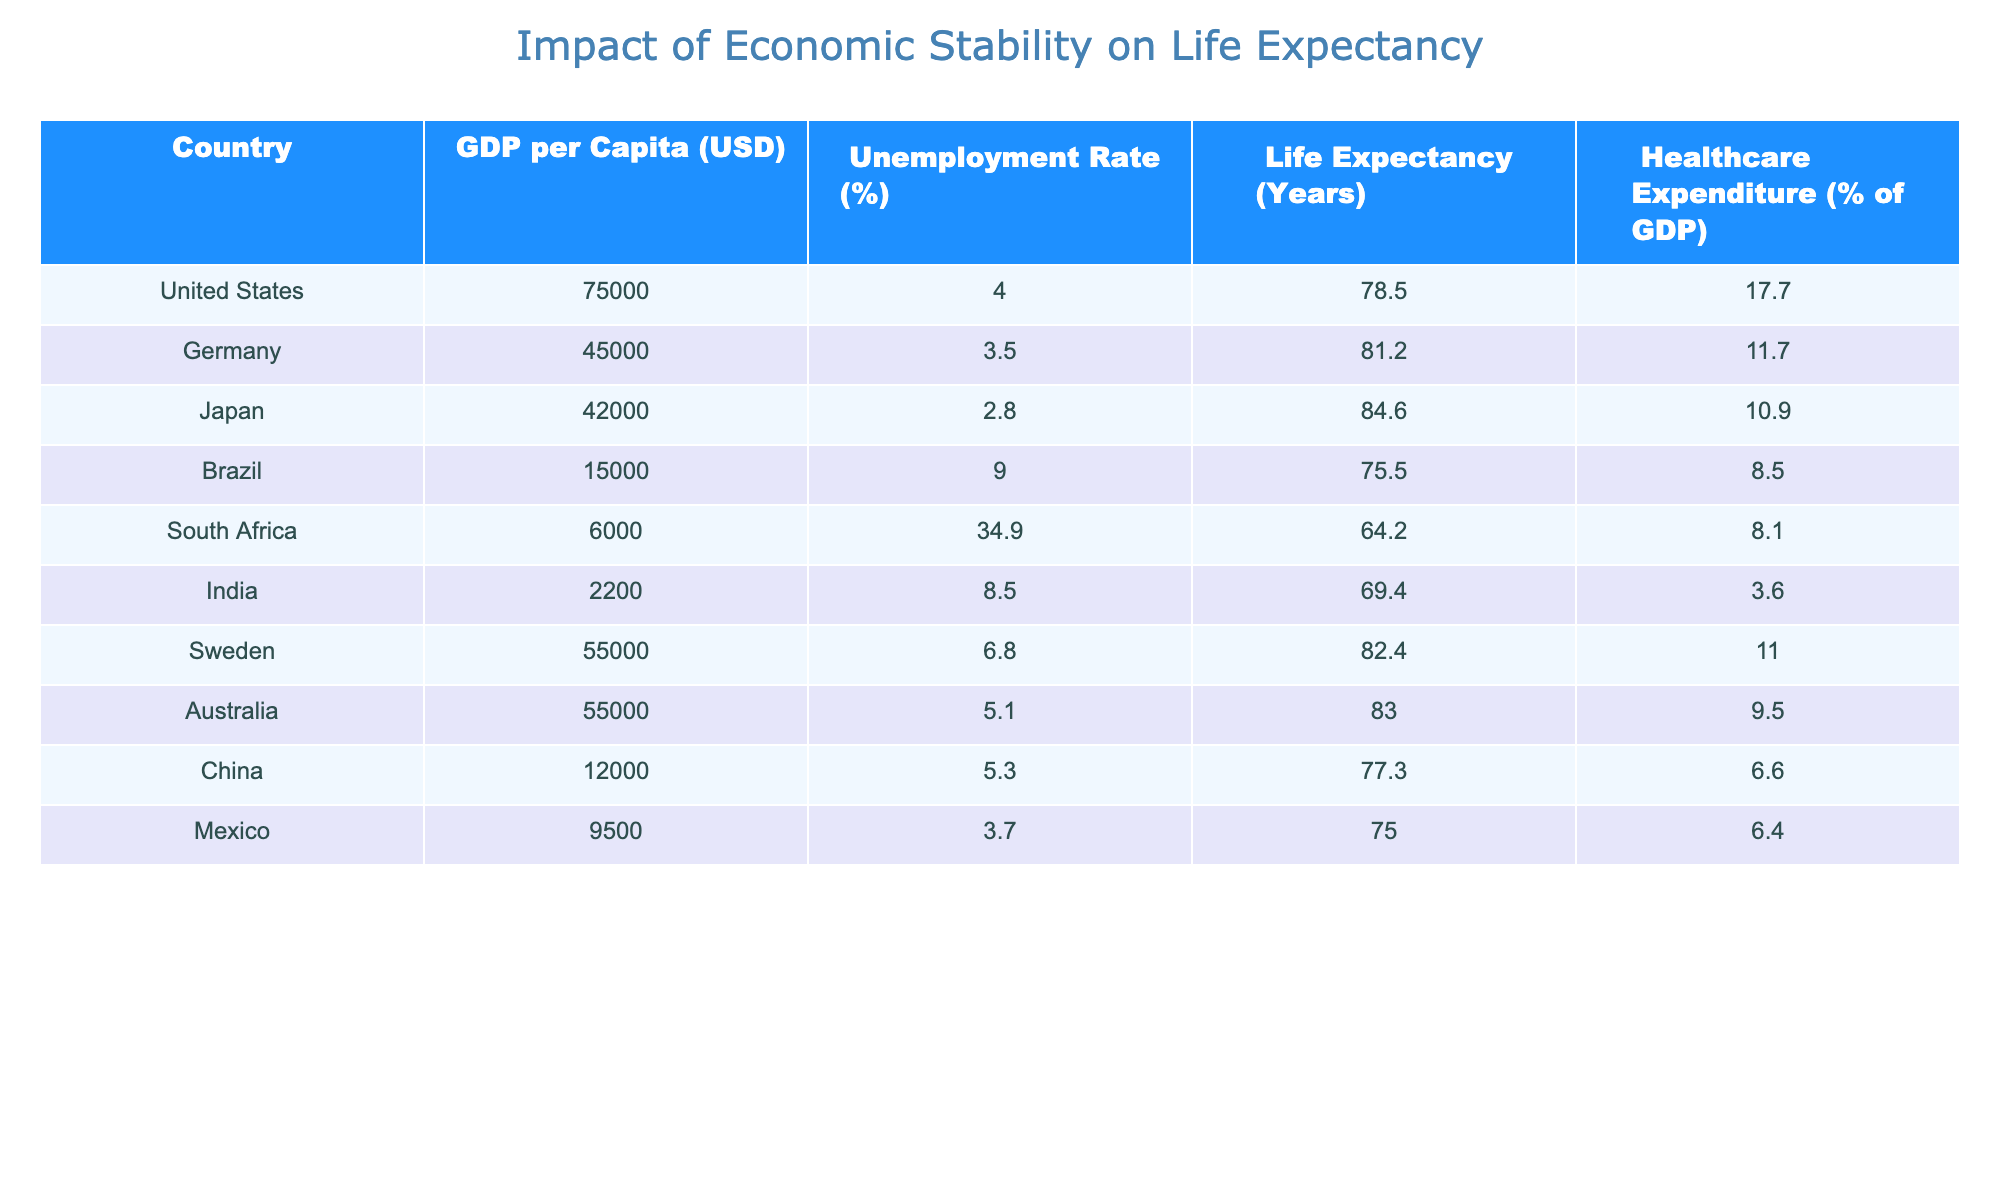What is the life expectancy in Japan? The life expectancy for Japan is listed directly in the table. Looking at the "Life Expectancy (Years)" column for Japan provides the value.
Answer: 84.6 Which country has the highest GDP per capita? The "GDP per Capita (USD)" column shows the values for all countries. By scanning through the list, the United States has the highest GDP per capita at 75000 USD.
Answer: United States Is South Africa's unemployment rate higher than 30%? Checking the "Unemployment Rate (%)" column for South Africa shows a value of 34.9%, which is indeed higher than 30%.
Answer: Yes What is the average life expectancy of countries with a GDP per capita above 40,000 USD? The countries with a GDP per capita above 40,000 USD are the United States, Germany, Japan, Sweden, and Australia. Their life expectancies are 78.5, 81.2, 84.6, 82.4, and 83.0 years respectively. We sum these values: 78.5 + 81.2 + 84.6 + 82.4 + 83.0 = 409.7. Dividing by 5 (the number of data points), we get an average of 409.7 / 5 = 81.94.
Answer: 81.94 Does higher healthcare expenditure generally correlate with longer life expectancy in the table? To determine if there is a correlation, we can analyze the healthcare expenditure and life expectancy for all countries. For example, the United States has a high healthcare expenditure of 17.7% and a life expectancy of 78.5 years, while South Africa has low healthcare expenditure of 8.1% and an even lower life expectancy of 64.2 years. However, Japan, with a healthcare expenditure of 10.9%, has a high life expectancy of 84.6 years. We can identify some correlation, but it's not consistent.
Answer: No, it is not consistent What is the life expectancy difference between Brazil and India? To find the difference, we look up the life expectancy for Brazil, which is 75.5 years, and India, which is 69.4 years. The difference is calculated as 75.5 - 69.4 = 6.1 years.
Answer: 6.1 years 